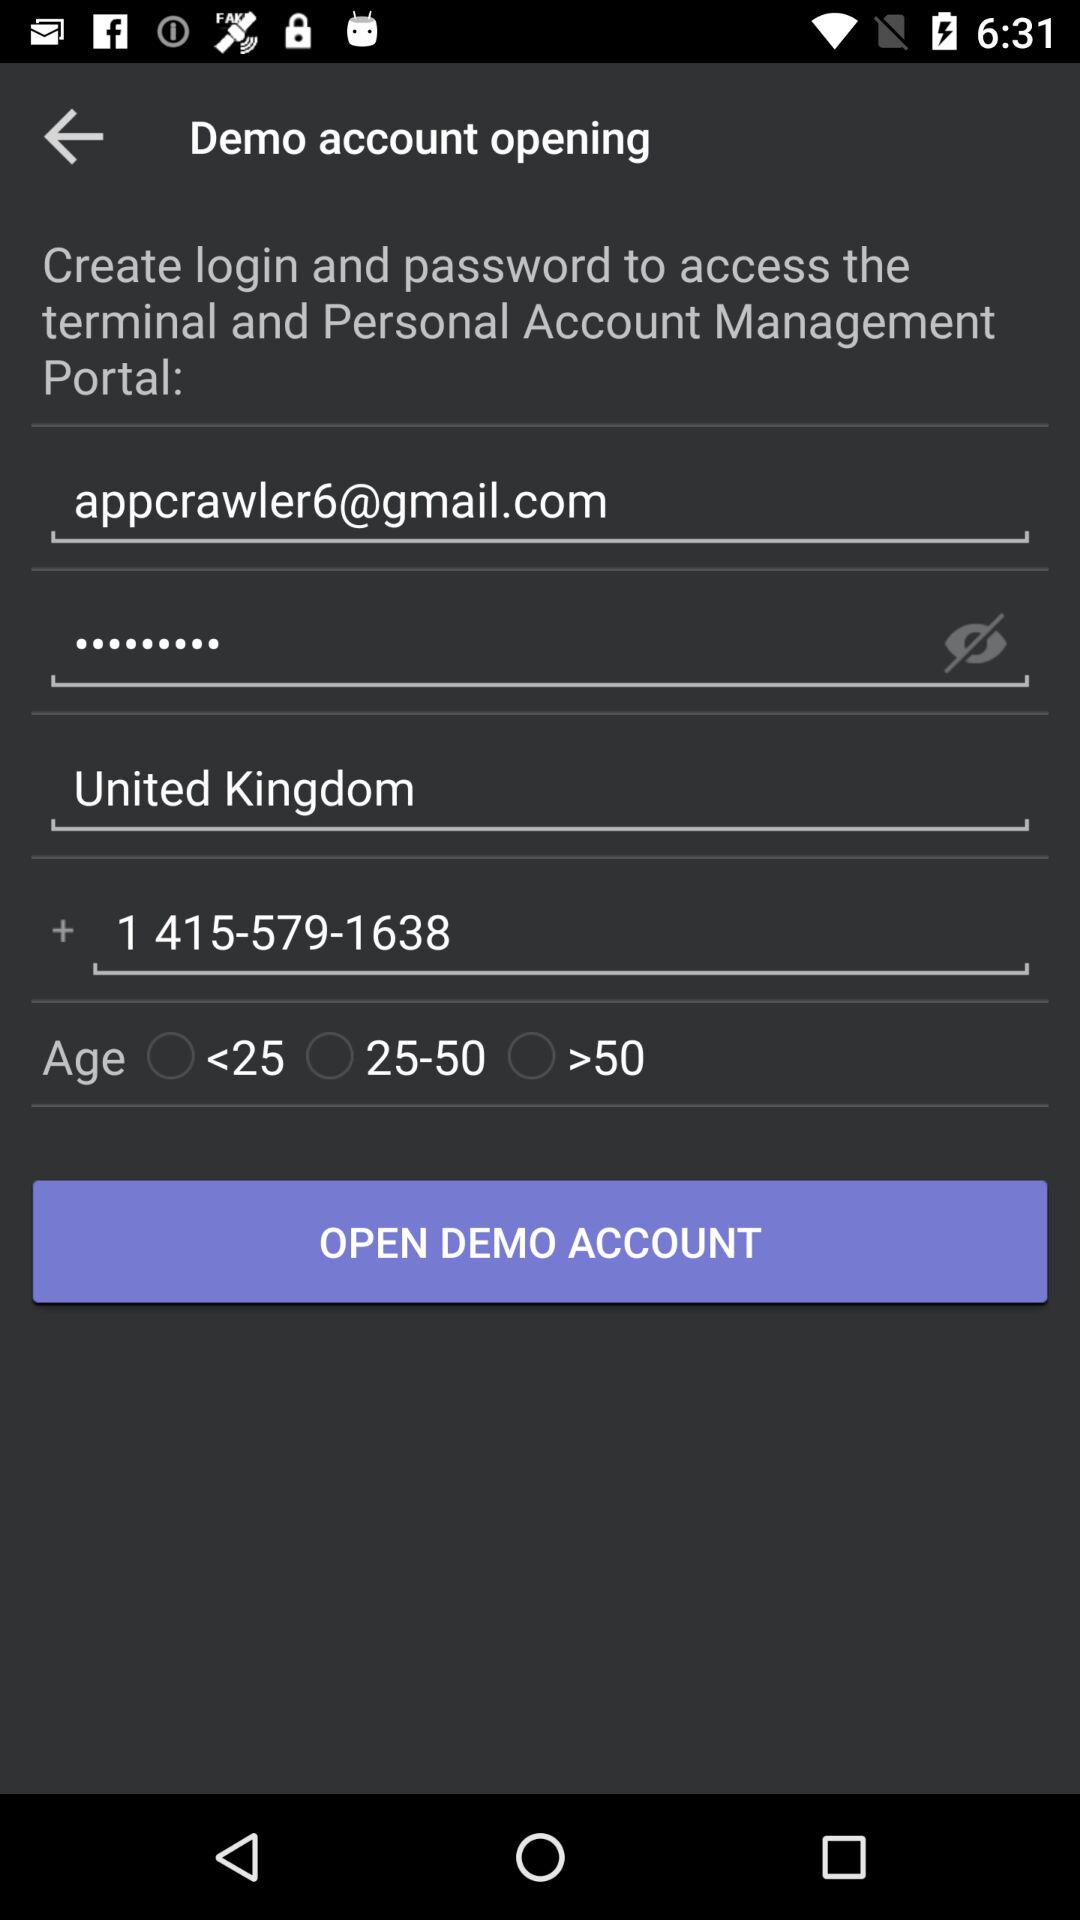How many text input fields are there on the page?
Answer the question using a single word or phrase. 4 